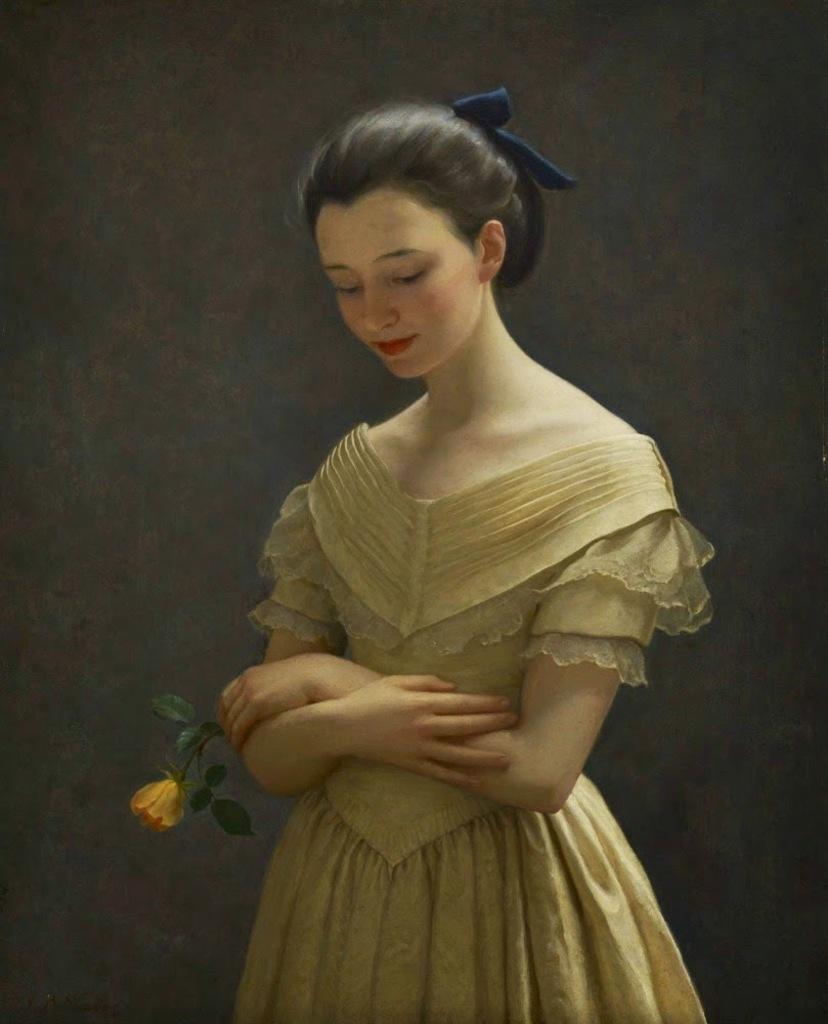Could you give a brief overview of what you see in this image? The picture is a painting. In the center of the picture there is a woman holding rose. The background is black. 